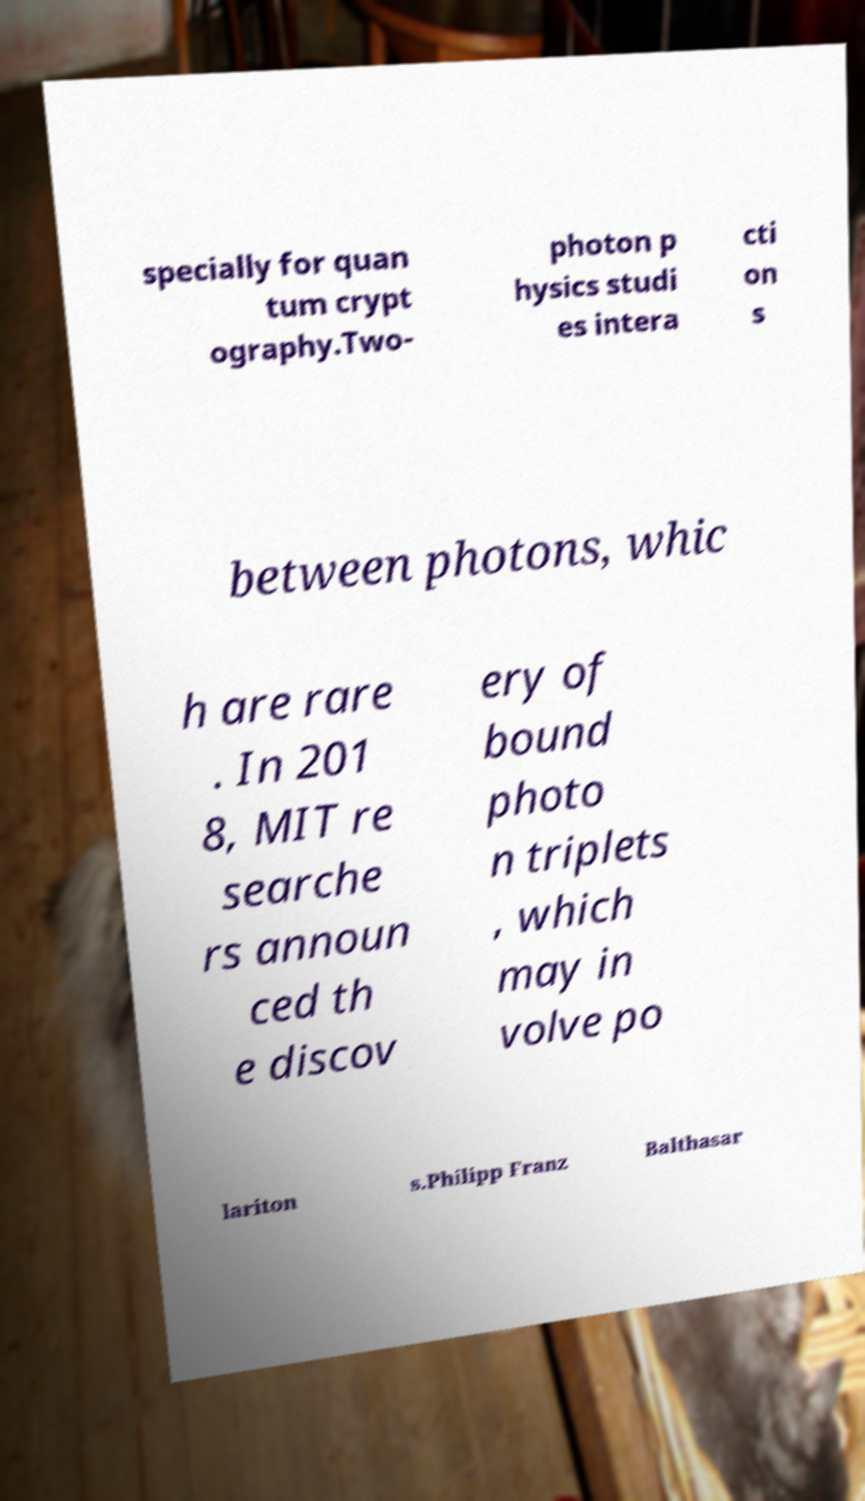What messages or text are displayed in this image? I need them in a readable, typed format. specially for quan tum crypt ography.Two- photon p hysics studi es intera cti on s between photons, whic h are rare . In 201 8, MIT re searche rs announ ced th e discov ery of bound photo n triplets , which may in volve po lariton s.Philipp Franz Balthasar 